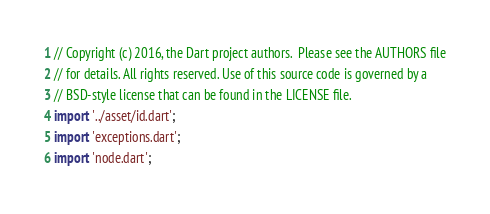<code> <loc_0><loc_0><loc_500><loc_500><_Dart_>// Copyright (c) 2016, the Dart project authors.  Please see the AUTHORS file
// for details. All rights reserved. Use of this source code is governed by a
// BSD-style license that can be found in the LICENSE file.
import '../asset/id.dart';
import 'exceptions.dart';
import 'node.dart';
</code> 